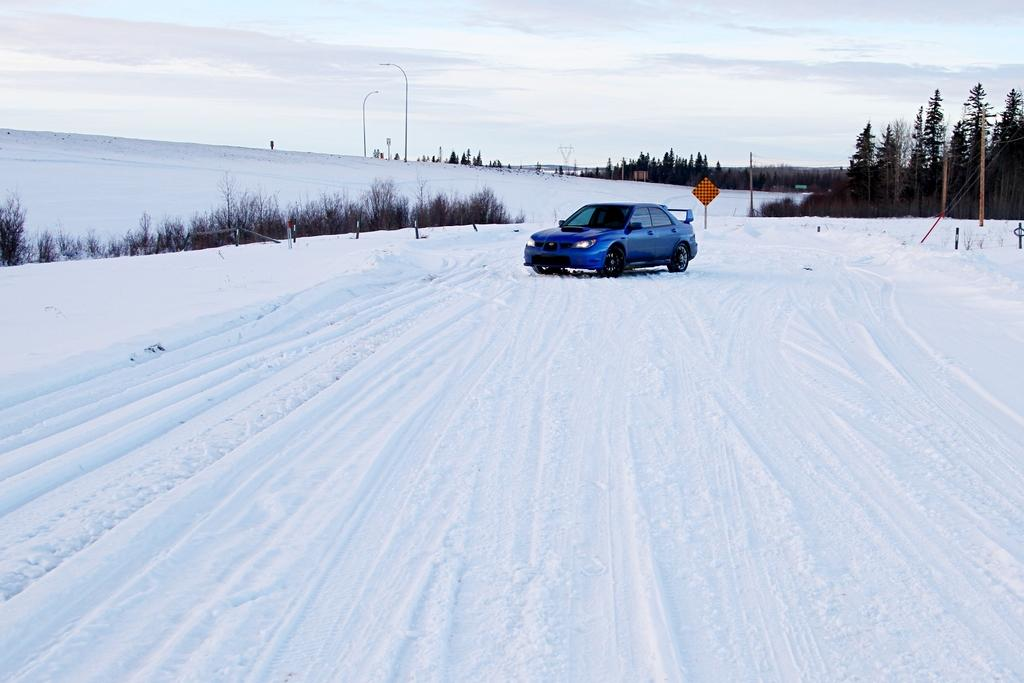What type of vehicle is in the image? There is a blue car in the image. What is the car's location in the image? The car is on the snow. What type of vegetation can be seen in the image? There are trees in the image. What other structures are present in the image? There are wires and poles in the image. What is visible at the top of the image? The sky is visible at the top of the image. Can you see the arm of the person playing baseball in the image? There is no person playing baseball or any arm visible in the image. What type of sport is being played on the snow in the image? There is no sport being played in the image; it only shows a blue car on the snow. 